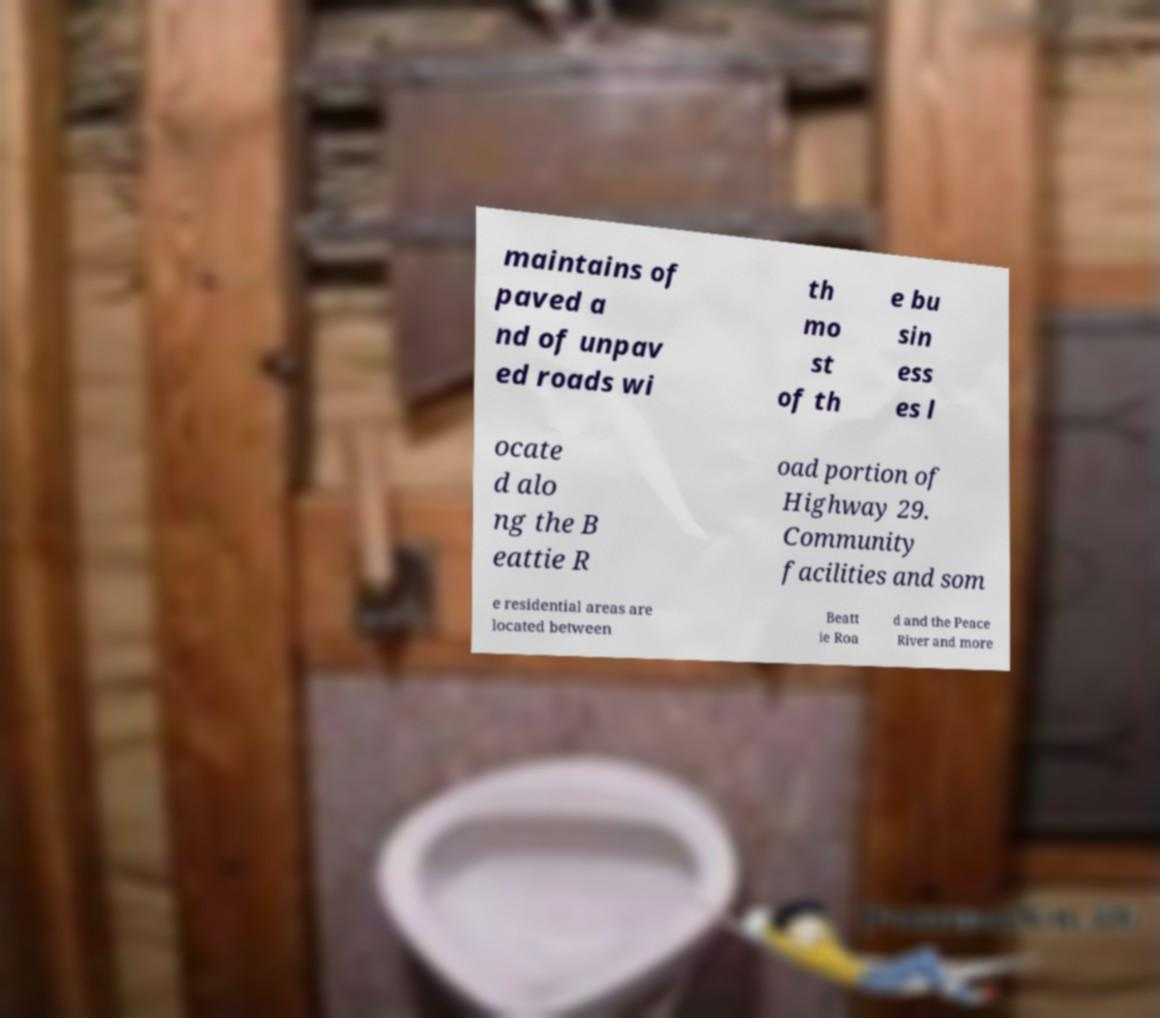What messages or text are displayed in this image? I need them in a readable, typed format. maintains of paved a nd of unpav ed roads wi th mo st of th e bu sin ess es l ocate d alo ng the B eattie R oad portion of Highway 29. Community facilities and som e residential areas are located between Beatt ie Roa d and the Peace River and more 